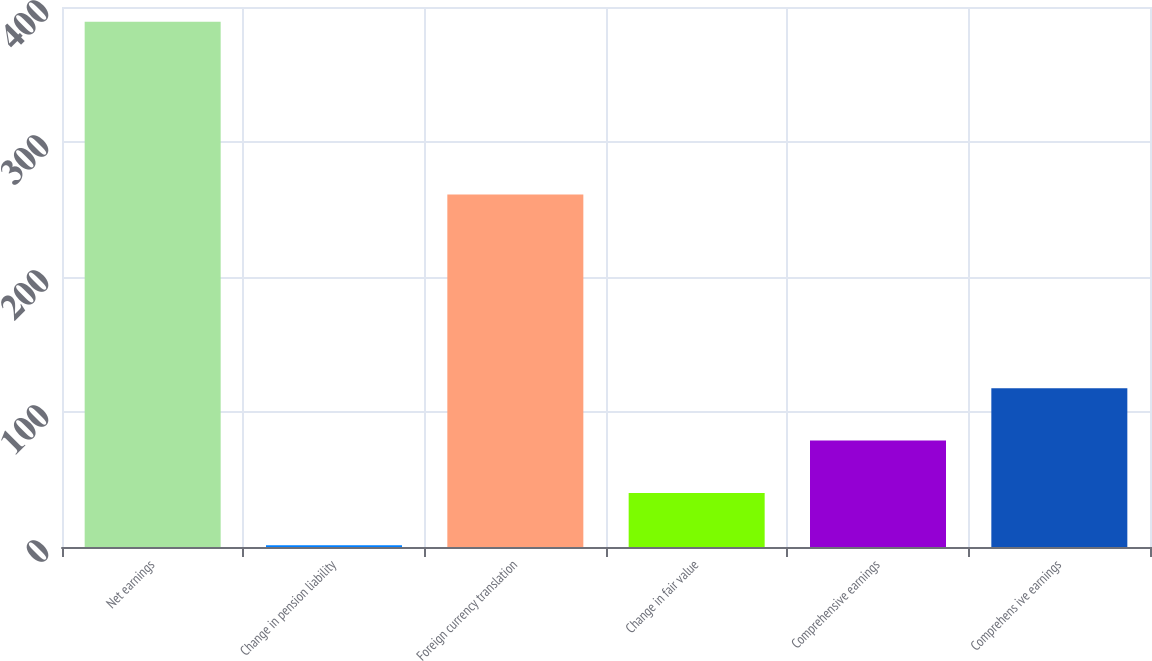Convert chart. <chart><loc_0><loc_0><loc_500><loc_500><bar_chart><fcel>Net earnings<fcel>Change in pension liability<fcel>Foreign currency translation<fcel>Change in fair value<fcel>Comprehensive earnings<fcel>Comprehens ive earnings<nl><fcel>389.1<fcel>1.3<fcel>261.1<fcel>40.08<fcel>78.86<fcel>117.64<nl></chart> 